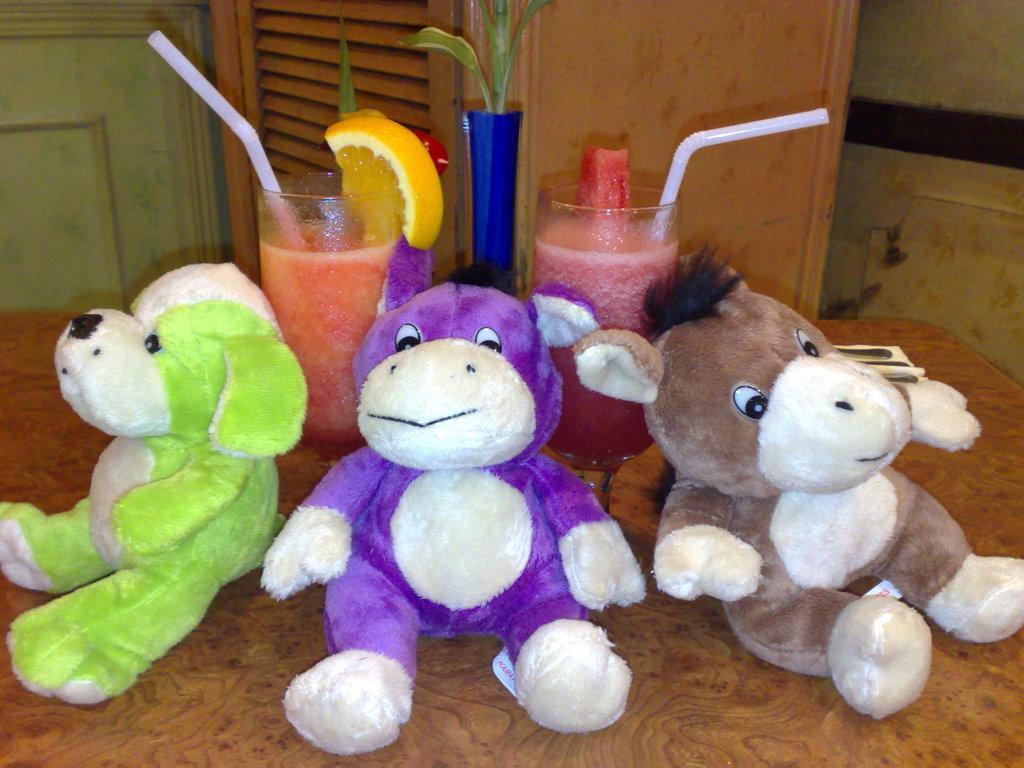How would you summarize this image in a sentence or two? In this image I see 3 soft toys in which this one is of white and green in color, this one is of white and purple in color and this one is of white and brown in color and I see glasses in which there are 2 straws and I see a piece of a fruit and these things are on the brown color surface and I see the blue color thing over here and I see the wall. 